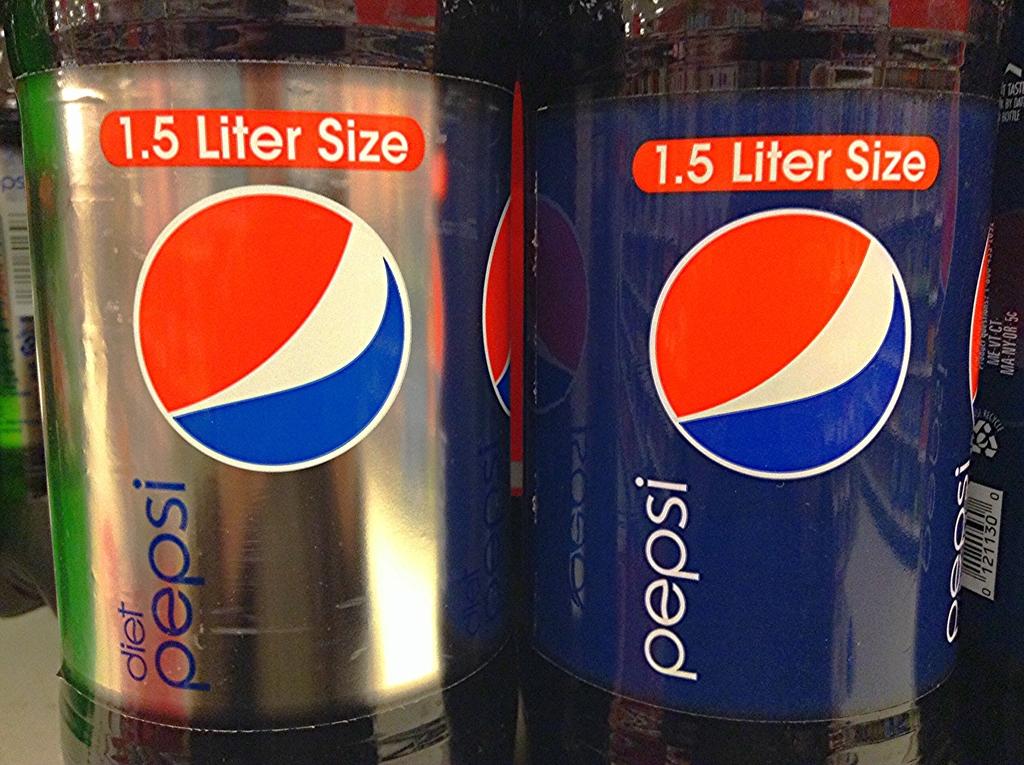How many liters are the pepsi drinks?
Your answer should be very brief. 1.5. What brand of soda is in the bottles?
Provide a succinct answer. Pepsi. 